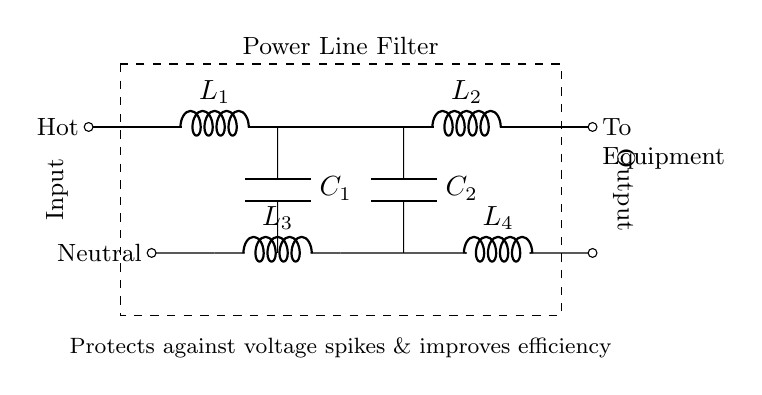What are the components used in this filter? The filter includes inductors (L1, L2, L3, L4) and capacitors (C1, C2). These are indicated in the diagram where the components are labeled.
Answer: Inductors and capacitors What is the function of this circuit? The primary function is to protect against voltage spikes and improve energy efficiency as stated in the explanation below the circuit.
Answer: Voltage spike protection and energy efficiency How many inductors are present in the circuit? There are four inductors labeled L1, L2, L3, and L4 in the circuit diagram. This count is based on visually identifying the labeled L components.
Answer: Four Where do the connections to the equipment take place? The connections to the equipment occur at the output labeled as "To Equipment" on the right side of the diagram. This is where the filtered power is sent after processing.
Answer: Right side Which components are connected in parallel? The capacitors C1 and C2 are connected in parallel with their respective inductors L1 and L2 because they connect to the same nodes at the top and bottom of the circuit.
Answer: C1 and C2 Why is a power line filter needed for electronic equipment? A power line filter is necessary to eliminate interference and protect against voltage spikes that can damage equipment, and it improves efficiency by reducing unwanted electrical noise. This reasoning can be inferred from the circuit's purpose description.
Answer: To eliminate interference and protect equipment What type of configuration is used for the inductors in this circuit? The inductors are arranged in series with each other as they are aligned one after the other without parallel branches between them, which is a common configuration in filter designs.
Answer: Series configuration 